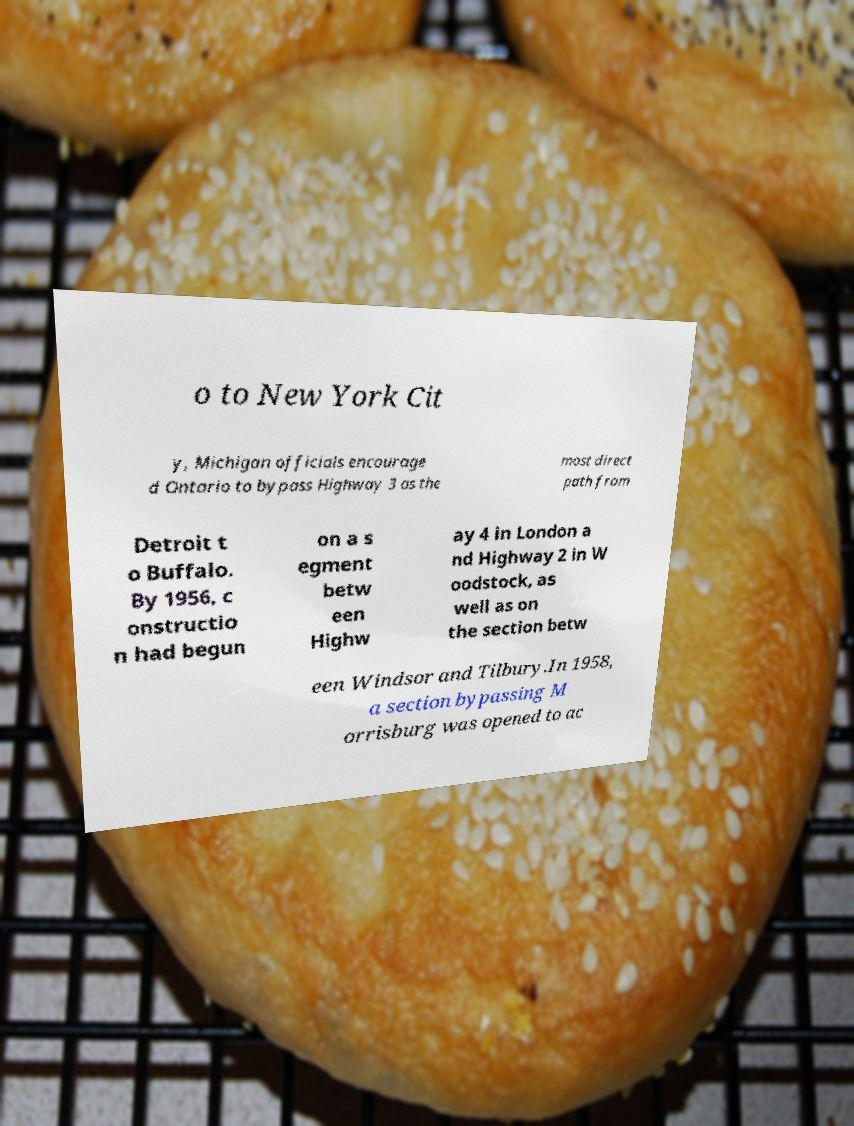Could you extract and type out the text from this image? o to New York Cit y, Michigan officials encourage d Ontario to bypass Highway 3 as the most direct path from Detroit t o Buffalo. By 1956, c onstructio n had begun on a s egment betw een Highw ay 4 in London a nd Highway 2 in W oodstock, as well as on the section betw een Windsor and Tilbury.In 1958, a section bypassing M orrisburg was opened to ac 